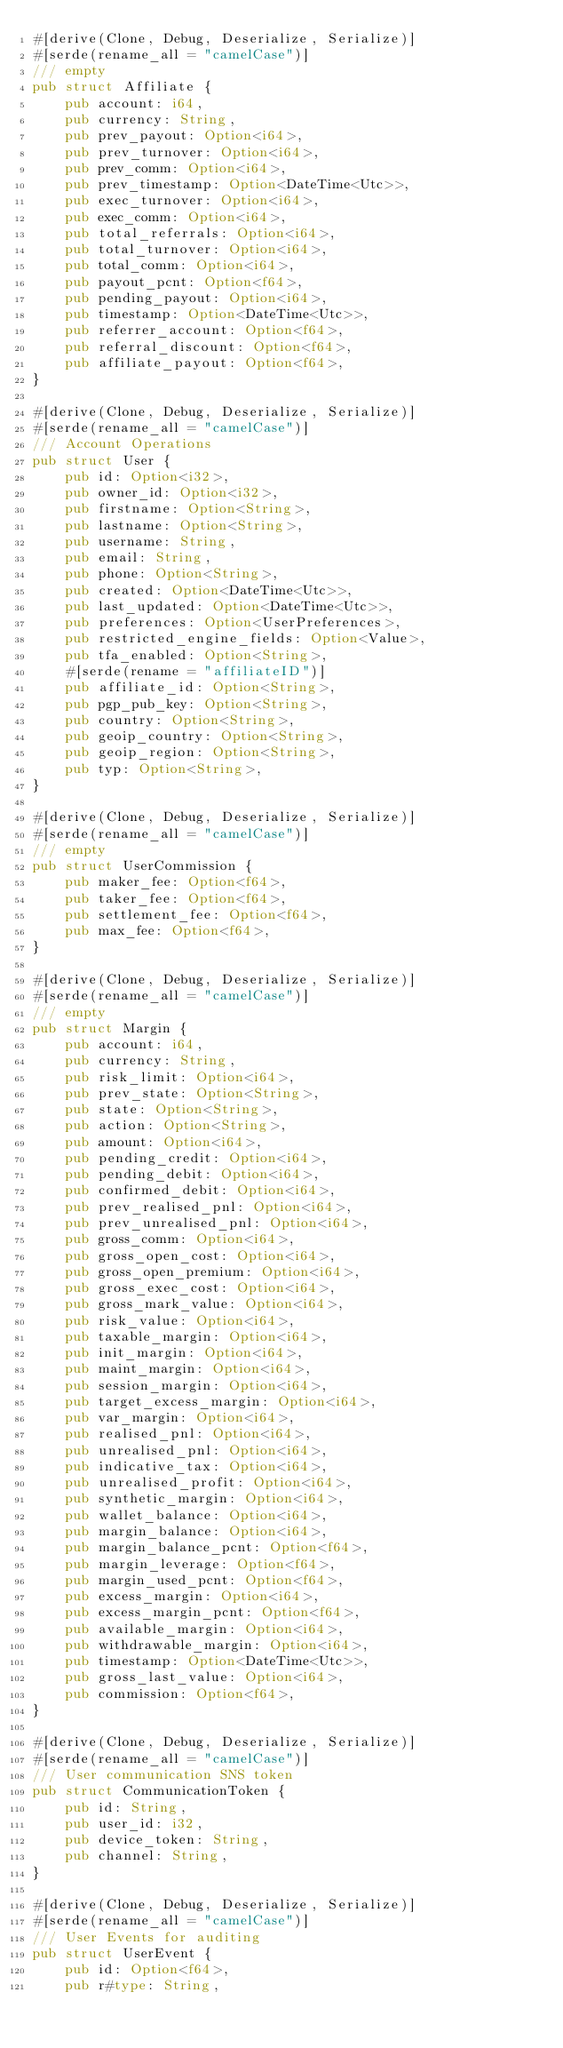Convert code to text. <code><loc_0><loc_0><loc_500><loc_500><_Rust_>#[derive(Clone, Debug, Deserialize, Serialize)]
#[serde(rename_all = "camelCase")]
/// empty
pub struct Affiliate {
    pub account: i64,
    pub currency: String,
    pub prev_payout: Option<i64>,
    pub prev_turnover: Option<i64>,
    pub prev_comm: Option<i64>,
    pub prev_timestamp: Option<DateTime<Utc>>,
    pub exec_turnover: Option<i64>,
    pub exec_comm: Option<i64>,
    pub total_referrals: Option<i64>,
    pub total_turnover: Option<i64>,
    pub total_comm: Option<i64>,
    pub payout_pcnt: Option<f64>,
    pub pending_payout: Option<i64>,
    pub timestamp: Option<DateTime<Utc>>,
    pub referrer_account: Option<f64>,
    pub referral_discount: Option<f64>,
    pub affiliate_payout: Option<f64>,
}

#[derive(Clone, Debug, Deserialize, Serialize)]
#[serde(rename_all = "camelCase")]
/// Account Operations
pub struct User {
    pub id: Option<i32>,
    pub owner_id: Option<i32>,
    pub firstname: Option<String>,
    pub lastname: Option<String>,
    pub username: String,
    pub email: String,
    pub phone: Option<String>,
    pub created: Option<DateTime<Utc>>,
    pub last_updated: Option<DateTime<Utc>>,
    pub preferences: Option<UserPreferences>,
    pub restricted_engine_fields: Option<Value>,
    pub tfa_enabled: Option<String>,
    #[serde(rename = "affiliateID")]
    pub affiliate_id: Option<String>,
    pub pgp_pub_key: Option<String>,
    pub country: Option<String>,
    pub geoip_country: Option<String>,
    pub geoip_region: Option<String>,
    pub typ: Option<String>,
}

#[derive(Clone, Debug, Deserialize, Serialize)]
#[serde(rename_all = "camelCase")]
/// empty
pub struct UserCommission {
    pub maker_fee: Option<f64>,
    pub taker_fee: Option<f64>,
    pub settlement_fee: Option<f64>,
    pub max_fee: Option<f64>,
}

#[derive(Clone, Debug, Deserialize, Serialize)]
#[serde(rename_all = "camelCase")]
/// empty
pub struct Margin {
    pub account: i64,
    pub currency: String,
    pub risk_limit: Option<i64>,
    pub prev_state: Option<String>,
    pub state: Option<String>,
    pub action: Option<String>,
    pub amount: Option<i64>,
    pub pending_credit: Option<i64>,
    pub pending_debit: Option<i64>,
    pub confirmed_debit: Option<i64>,
    pub prev_realised_pnl: Option<i64>,
    pub prev_unrealised_pnl: Option<i64>,
    pub gross_comm: Option<i64>,
    pub gross_open_cost: Option<i64>,
    pub gross_open_premium: Option<i64>,
    pub gross_exec_cost: Option<i64>,
    pub gross_mark_value: Option<i64>,
    pub risk_value: Option<i64>,
    pub taxable_margin: Option<i64>,
    pub init_margin: Option<i64>,
    pub maint_margin: Option<i64>,
    pub session_margin: Option<i64>,
    pub target_excess_margin: Option<i64>,
    pub var_margin: Option<i64>,
    pub realised_pnl: Option<i64>,
    pub unrealised_pnl: Option<i64>,
    pub indicative_tax: Option<i64>,
    pub unrealised_profit: Option<i64>,
    pub synthetic_margin: Option<i64>,
    pub wallet_balance: Option<i64>,
    pub margin_balance: Option<i64>,
    pub margin_balance_pcnt: Option<f64>,
    pub margin_leverage: Option<f64>,
    pub margin_used_pcnt: Option<f64>,
    pub excess_margin: Option<i64>,
    pub excess_margin_pcnt: Option<f64>,
    pub available_margin: Option<i64>,
    pub withdrawable_margin: Option<i64>,
    pub timestamp: Option<DateTime<Utc>>,
    pub gross_last_value: Option<i64>,
    pub commission: Option<f64>,
}

#[derive(Clone, Debug, Deserialize, Serialize)]
#[serde(rename_all = "camelCase")]
/// User communication SNS token
pub struct CommunicationToken {
    pub id: String,
    pub user_id: i32,
    pub device_token: String,
    pub channel: String,
}

#[derive(Clone, Debug, Deserialize, Serialize)]
#[serde(rename_all = "camelCase")]
/// User Events for auditing
pub struct UserEvent {
    pub id: Option<f64>,
    pub r#type: String,</code> 